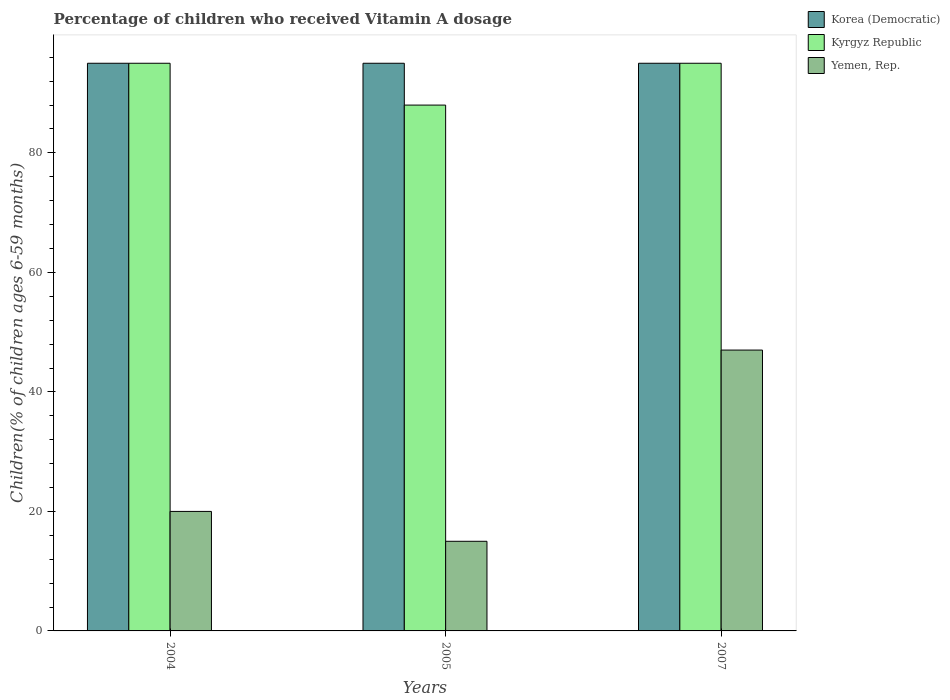How many bars are there on the 1st tick from the left?
Give a very brief answer. 3. How many bars are there on the 2nd tick from the right?
Offer a very short reply. 3. What is the label of the 2nd group of bars from the left?
Provide a short and direct response. 2005. In how many cases, is the number of bars for a given year not equal to the number of legend labels?
Provide a succinct answer. 0. What is the percentage of children who received Vitamin A dosage in Korea (Democratic) in 2005?
Offer a very short reply. 95. In which year was the percentage of children who received Vitamin A dosage in Yemen, Rep. maximum?
Offer a terse response. 2007. What is the total percentage of children who received Vitamin A dosage in Yemen, Rep. in the graph?
Ensure brevity in your answer.  82. What is the difference between the percentage of children who received Vitamin A dosage in Yemen, Rep. in 2004 and that in 2007?
Your answer should be compact. -27. What is the difference between the percentage of children who received Vitamin A dosage in Korea (Democratic) in 2007 and the percentage of children who received Vitamin A dosage in Kyrgyz Republic in 2005?
Offer a terse response. 7. What is the average percentage of children who received Vitamin A dosage in Kyrgyz Republic per year?
Your answer should be compact. 92.67. In the year 2004, what is the difference between the percentage of children who received Vitamin A dosage in Yemen, Rep. and percentage of children who received Vitamin A dosage in Kyrgyz Republic?
Offer a very short reply. -75. In how many years, is the percentage of children who received Vitamin A dosage in Yemen, Rep. greater than 40 %?
Ensure brevity in your answer.  1. Is the difference between the percentage of children who received Vitamin A dosage in Yemen, Rep. in 2005 and 2007 greater than the difference between the percentage of children who received Vitamin A dosage in Kyrgyz Republic in 2005 and 2007?
Give a very brief answer. No. What does the 2nd bar from the left in 2004 represents?
Provide a short and direct response. Kyrgyz Republic. What does the 2nd bar from the right in 2004 represents?
Your response must be concise. Kyrgyz Republic. Is it the case that in every year, the sum of the percentage of children who received Vitamin A dosage in Korea (Democratic) and percentage of children who received Vitamin A dosage in Yemen, Rep. is greater than the percentage of children who received Vitamin A dosage in Kyrgyz Republic?
Offer a terse response. Yes. Are all the bars in the graph horizontal?
Offer a terse response. No. How many years are there in the graph?
Provide a short and direct response. 3. Are the values on the major ticks of Y-axis written in scientific E-notation?
Offer a terse response. No. Does the graph contain grids?
Make the answer very short. No. How many legend labels are there?
Provide a succinct answer. 3. What is the title of the graph?
Ensure brevity in your answer.  Percentage of children who received Vitamin A dosage. What is the label or title of the X-axis?
Make the answer very short. Years. What is the label or title of the Y-axis?
Make the answer very short. Children(% of children ages 6-59 months). What is the Children(% of children ages 6-59 months) in Korea (Democratic) in 2004?
Provide a short and direct response. 95. What is the Children(% of children ages 6-59 months) of Yemen, Rep. in 2004?
Give a very brief answer. 20. What is the Children(% of children ages 6-59 months) in Kyrgyz Republic in 2005?
Ensure brevity in your answer.  88. What is the Children(% of children ages 6-59 months) of Yemen, Rep. in 2005?
Offer a very short reply. 15. What is the Children(% of children ages 6-59 months) in Yemen, Rep. in 2007?
Offer a terse response. 47. Across all years, what is the minimum Children(% of children ages 6-59 months) of Korea (Democratic)?
Your answer should be very brief. 95. What is the total Children(% of children ages 6-59 months) in Korea (Democratic) in the graph?
Your answer should be compact. 285. What is the total Children(% of children ages 6-59 months) in Kyrgyz Republic in the graph?
Offer a very short reply. 278. What is the total Children(% of children ages 6-59 months) of Yemen, Rep. in the graph?
Provide a succinct answer. 82. What is the difference between the Children(% of children ages 6-59 months) of Korea (Democratic) in 2004 and that in 2005?
Make the answer very short. 0. What is the difference between the Children(% of children ages 6-59 months) of Kyrgyz Republic in 2004 and that in 2005?
Keep it short and to the point. 7. What is the difference between the Children(% of children ages 6-59 months) in Yemen, Rep. in 2004 and that in 2005?
Keep it short and to the point. 5. What is the difference between the Children(% of children ages 6-59 months) in Kyrgyz Republic in 2004 and that in 2007?
Provide a short and direct response. 0. What is the difference between the Children(% of children ages 6-59 months) of Korea (Democratic) in 2005 and that in 2007?
Ensure brevity in your answer.  0. What is the difference between the Children(% of children ages 6-59 months) of Kyrgyz Republic in 2005 and that in 2007?
Your response must be concise. -7. What is the difference between the Children(% of children ages 6-59 months) in Yemen, Rep. in 2005 and that in 2007?
Give a very brief answer. -32. What is the difference between the Children(% of children ages 6-59 months) of Korea (Democratic) in 2004 and the Children(% of children ages 6-59 months) of Kyrgyz Republic in 2005?
Provide a succinct answer. 7. What is the difference between the Children(% of children ages 6-59 months) in Korea (Democratic) in 2004 and the Children(% of children ages 6-59 months) in Yemen, Rep. in 2005?
Offer a very short reply. 80. What is the difference between the Children(% of children ages 6-59 months) of Korea (Democratic) in 2004 and the Children(% of children ages 6-59 months) of Yemen, Rep. in 2007?
Provide a short and direct response. 48. What is the difference between the Children(% of children ages 6-59 months) in Kyrgyz Republic in 2004 and the Children(% of children ages 6-59 months) in Yemen, Rep. in 2007?
Keep it short and to the point. 48. What is the average Children(% of children ages 6-59 months) of Korea (Democratic) per year?
Provide a short and direct response. 95. What is the average Children(% of children ages 6-59 months) of Kyrgyz Republic per year?
Keep it short and to the point. 92.67. What is the average Children(% of children ages 6-59 months) in Yemen, Rep. per year?
Provide a succinct answer. 27.33. In the year 2005, what is the difference between the Children(% of children ages 6-59 months) in Korea (Democratic) and Children(% of children ages 6-59 months) in Yemen, Rep.?
Offer a terse response. 80. In the year 2007, what is the difference between the Children(% of children ages 6-59 months) of Korea (Democratic) and Children(% of children ages 6-59 months) of Yemen, Rep.?
Provide a succinct answer. 48. In the year 2007, what is the difference between the Children(% of children ages 6-59 months) of Kyrgyz Republic and Children(% of children ages 6-59 months) of Yemen, Rep.?
Your answer should be compact. 48. What is the ratio of the Children(% of children ages 6-59 months) in Korea (Democratic) in 2004 to that in 2005?
Give a very brief answer. 1. What is the ratio of the Children(% of children ages 6-59 months) in Kyrgyz Republic in 2004 to that in 2005?
Your answer should be very brief. 1.08. What is the ratio of the Children(% of children ages 6-59 months) in Yemen, Rep. in 2004 to that in 2005?
Provide a short and direct response. 1.33. What is the ratio of the Children(% of children ages 6-59 months) in Korea (Democratic) in 2004 to that in 2007?
Your response must be concise. 1. What is the ratio of the Children(% of children ages 6-59 months) of Yemen, Rep. in 2004 to that in 2007?
Make the answer very short. 0.43. What is the ratio of the Children(% of children ages 6-59 months) of Korea (Democratic) in 2005 to that in 2007?
Make the answer very short. 1. What is the ratio of the Children(% of children ages 6-59 months) of Kyrgyz Republic in 2005 to that in 2007?
Your answer should be very brief. 0.93. What is the ratio of the Children(% of children ages 6-59 months) of Yemen, Rep. in 2005 to that in 2007?
Keep it short and to the point. 0.32. What is the difference between the highest and the second highest Children(% of children ages 6-59 months) of Yemen, Rep.?
Provide a short and direct response. 27. What is the difference between the highest and the lowest Children(% of children ages 6-59 months) of Kyrgyz Republic?
Offer a terse response. 7. What is the difference between the highest and the lowest Children(% of children ages 6-59 months) in Yemen, Rep.?
Offer a terse response. 32. 